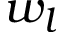Convert formula to latex. <formula><loc_0><loc_0><loc_500><loc_500>w _ { l }</formula> 